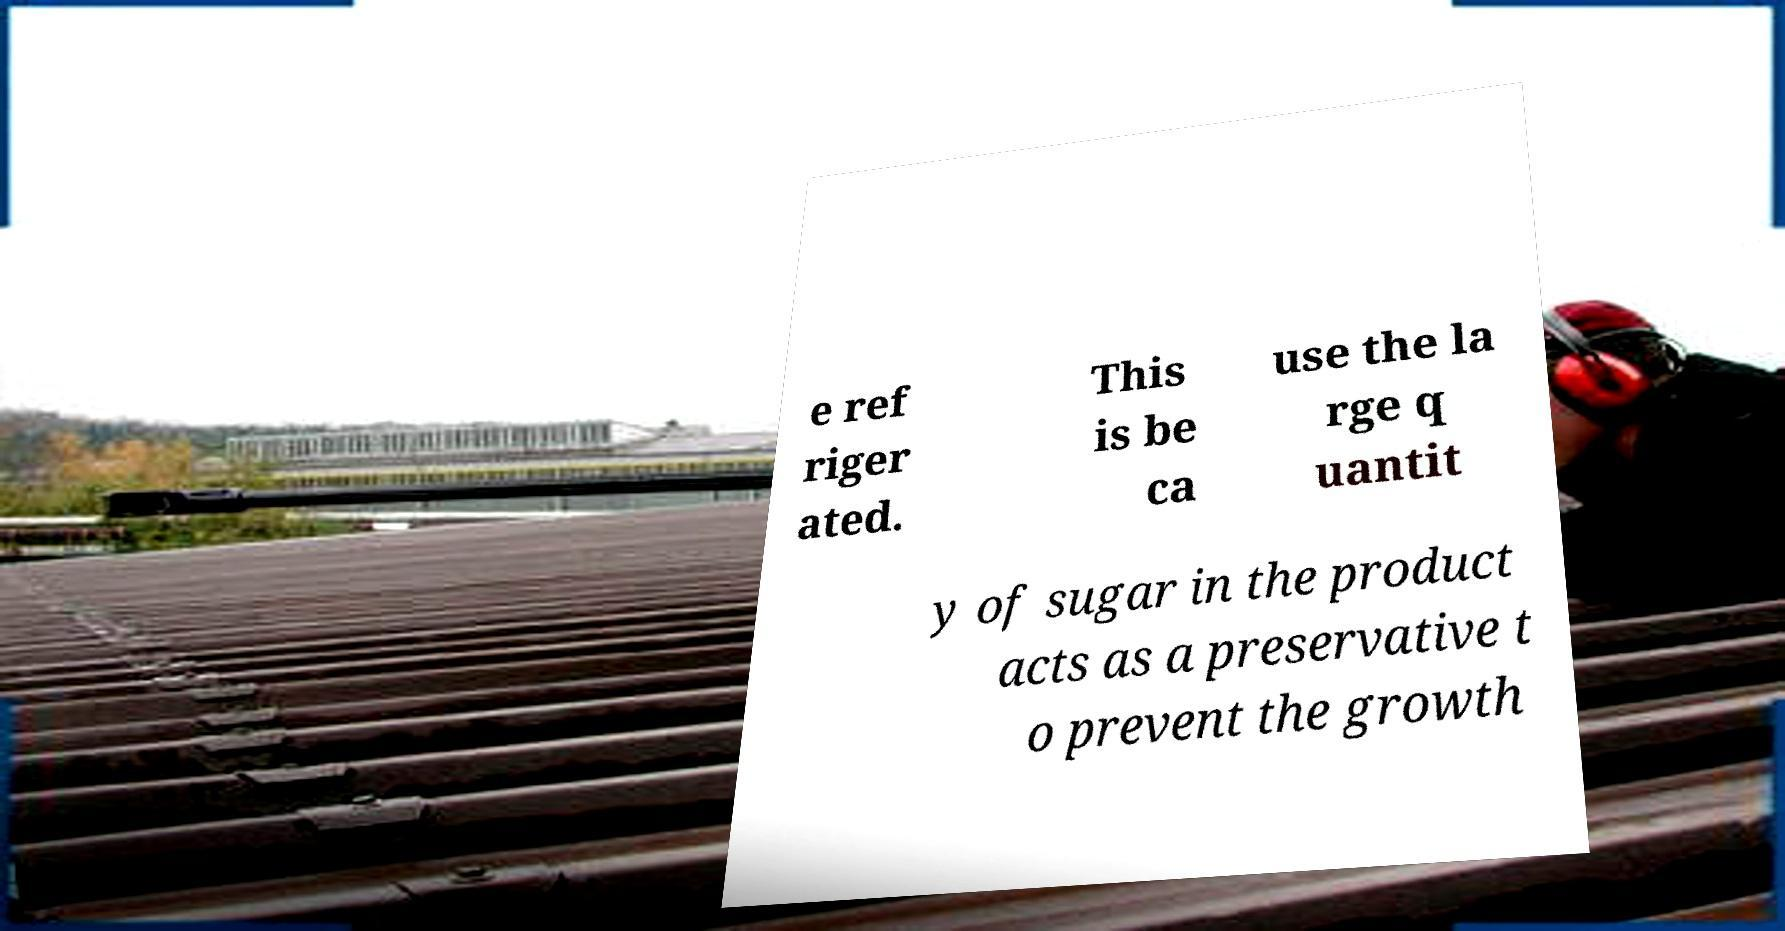For documentation purposes, I need the text within this image transcribed. Could you provide that? e ref riger ated. This is be ca use the la rge q uantit y of sugar in the product acts as a preservative t o prevent the growth 